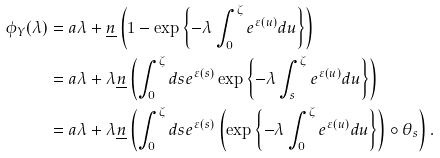<formula> <loc_0><loc_0><loc_500><loc_500>\phi _ { Y } ( \lambda ) & = a \lambda + \underline { n } \left ( 1 - \exp \left \{ { - \lambda } \int ^ { \zeta } _ { 0 } e ^ { \varepsilon ( u ) } d u \right \} \right ) \\ & = a \lambda + \lambda \underline { n } \left ( \int ^ { \zeta } _ { 0 } d s e ^ { \varepsilon ( s ) } \exp \left \{ - \lambda \int ^ { \zeta } _ { s } e ^ { \varepsilon ( u ) } d u \right \} \right ) \\ & = a \lambda + \lambda \underline { n } \left ( \int ^ { \zeta } _ { 0 } d s e ^ { \varepsilon ( s ) } \left ( \exp \left \{ - \lambda \int ^ { \zeta } _ { 0 } e ^ { \varepsilon ( u ) } d u \right \} \right ) \circ \theta _ { s } \right ) .</formula> 